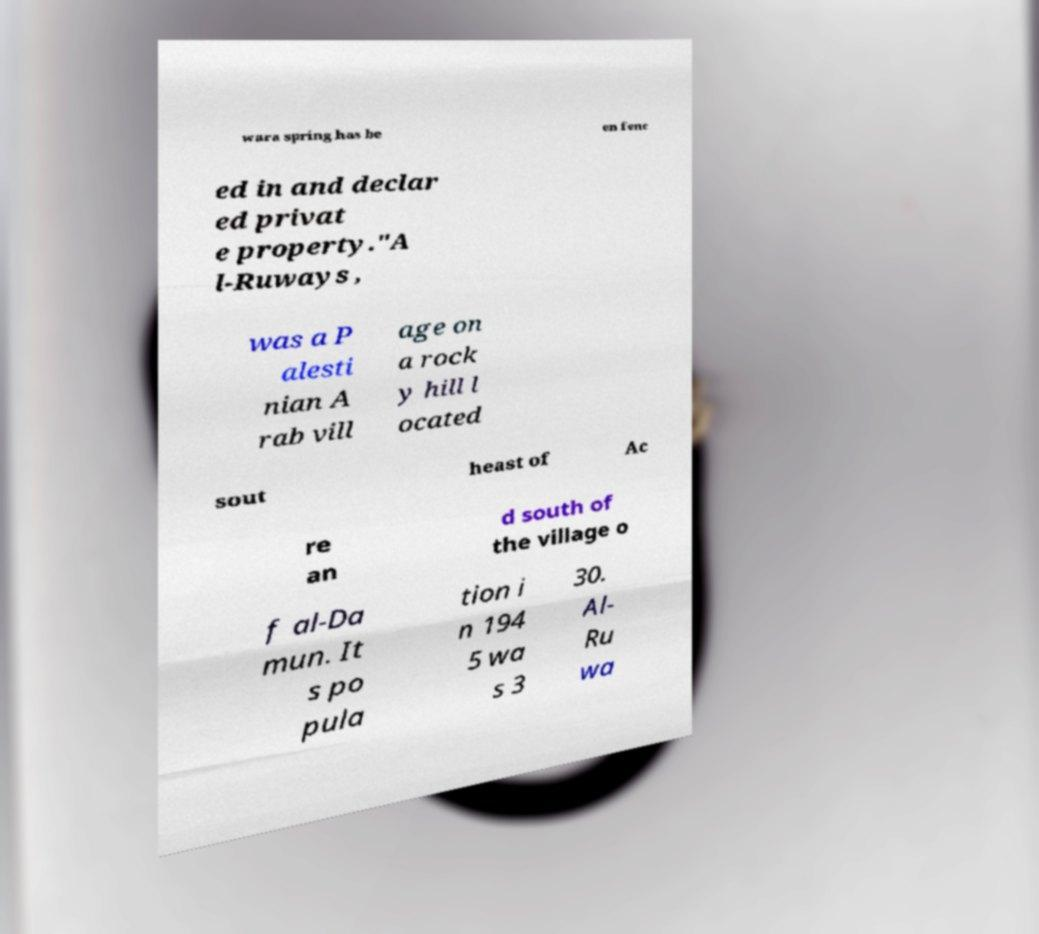There's text embedded in this image that I need extracted. Can you transcribe it verbatim? wara spring has be en fenc ed in and declar ed privat e property."A l-Ruways , was a P alesti nian A rab vill age on a rock y hill l ocated sout heast of Ac re an d south of the village o f al-Da mun. It s po pula tion i n 194 5 wa s 3 30. Al- Ru wa 